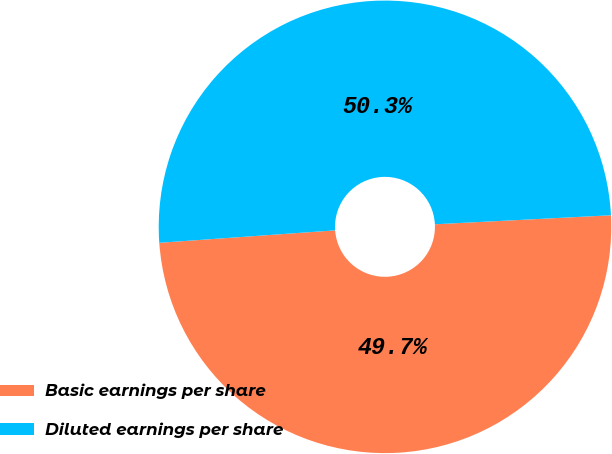Convert chart to OTSL. <chart><loc_0><loc_0><loc_500><loc_500><pie_chart><fcel>Basic earnings per share<fcel>Diluted earnings per share<nl><fcel>49.69%<fcel>50.31%<nl></chart> 